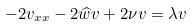<formula> <loc_0><loc_0><loc_500><loc_500>- 2 v _ { x x } - 2 \widehat { w } v + 2 \nu v = \lambda v</formula> 